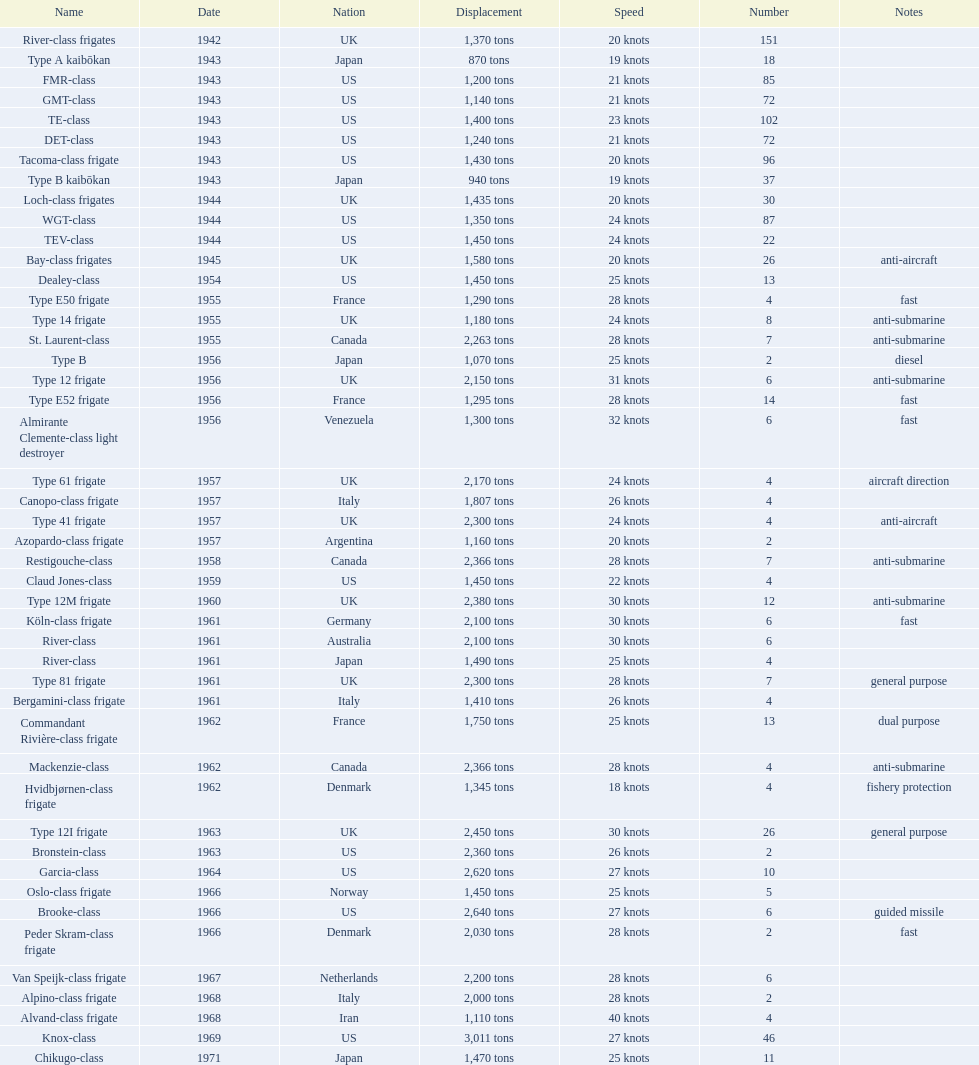In 1968 italy used alpino-class frigate. what was its top speed? 28 knots. 